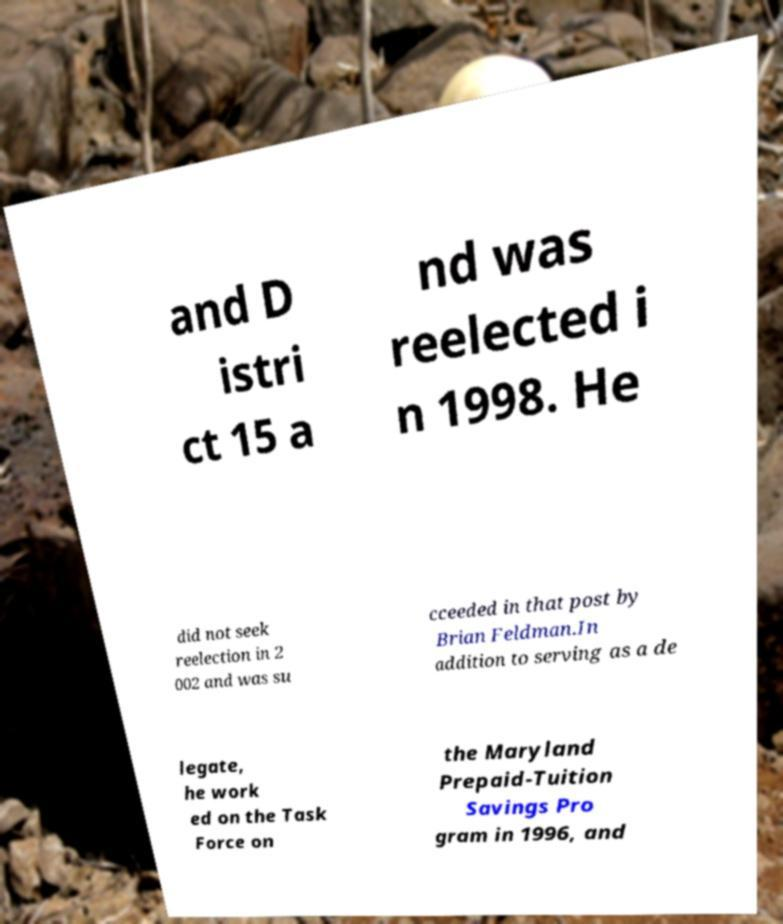I need the written content from this picture converted into text. Can you do that? and D istri ct 15 a nd was reelected i n 1998. He did not seek reelection in 2 002 and was su cceeded in that post by Brian Feldman.In addition to serving as a de legate, he work ed on the Task Force on the Maryland Prepaid-Tuition Savings Pro gram in 1996, and 